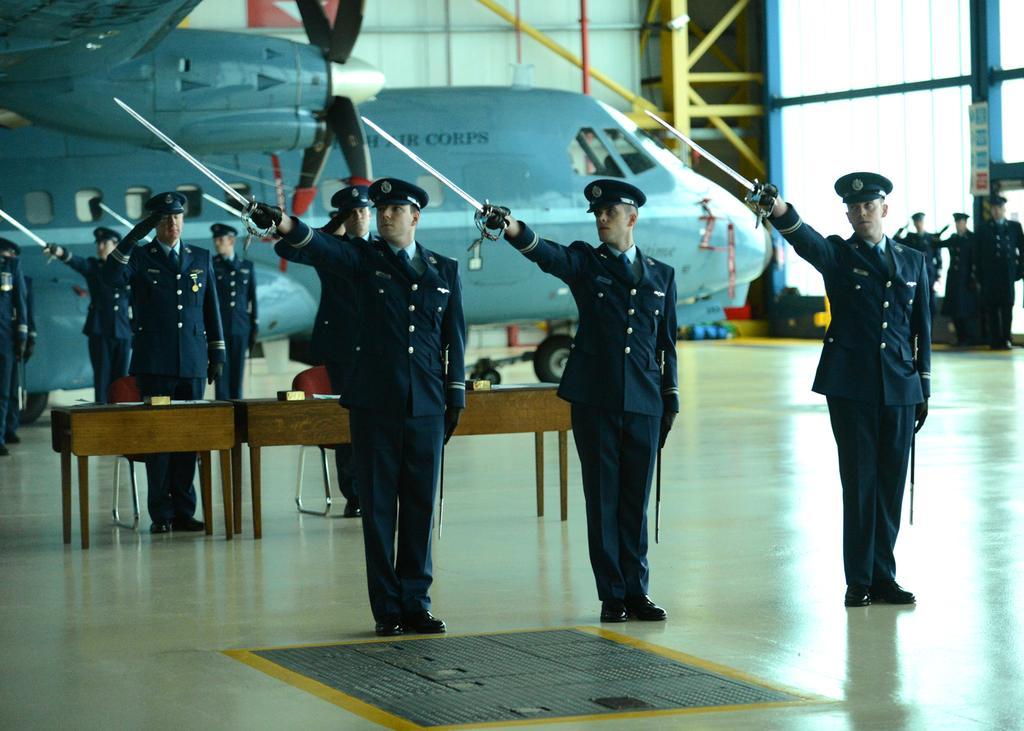Can you describe this image briefly? In this image in the foreground there are a group of people who are standing, and some of them are holding sticks in the background there is an airplane and some people are standing and there are some tables. On the tables there are some papers in the background there are some iron rods and window at the bottom there is a floor. 